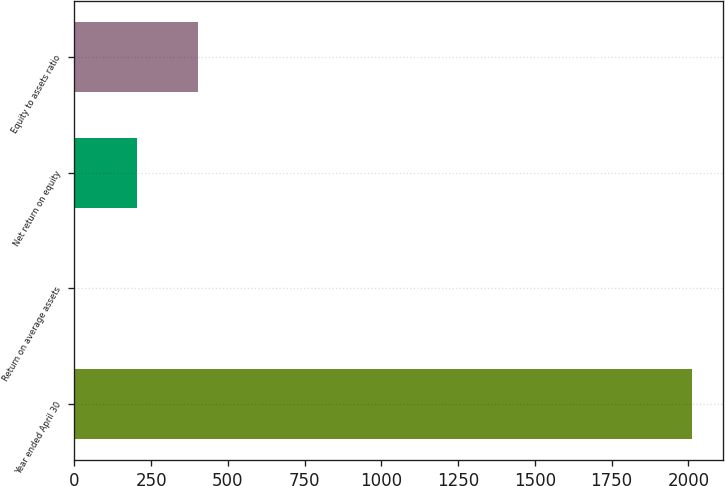<chart> <loc_0><loc_0><loc_500><loc_500><bar_chart><fcel>Year ended April 30<fcel>Return on average assets<fcel>Net return on equity<fcel>Equity to assets ratio<nl><fcel>2011<fcel>1.4<fcel>202.36<fcel>403.32<nl></chart> 